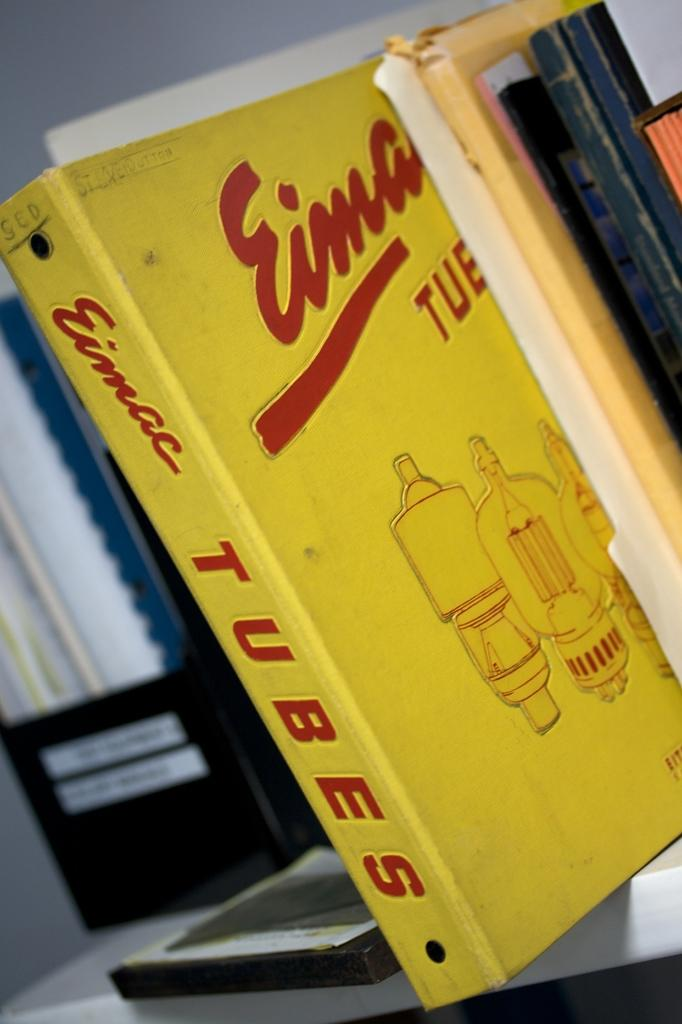<image>
Share a concise interpretation of the image provided. a row of books with one titled 'tubes' by eimac 